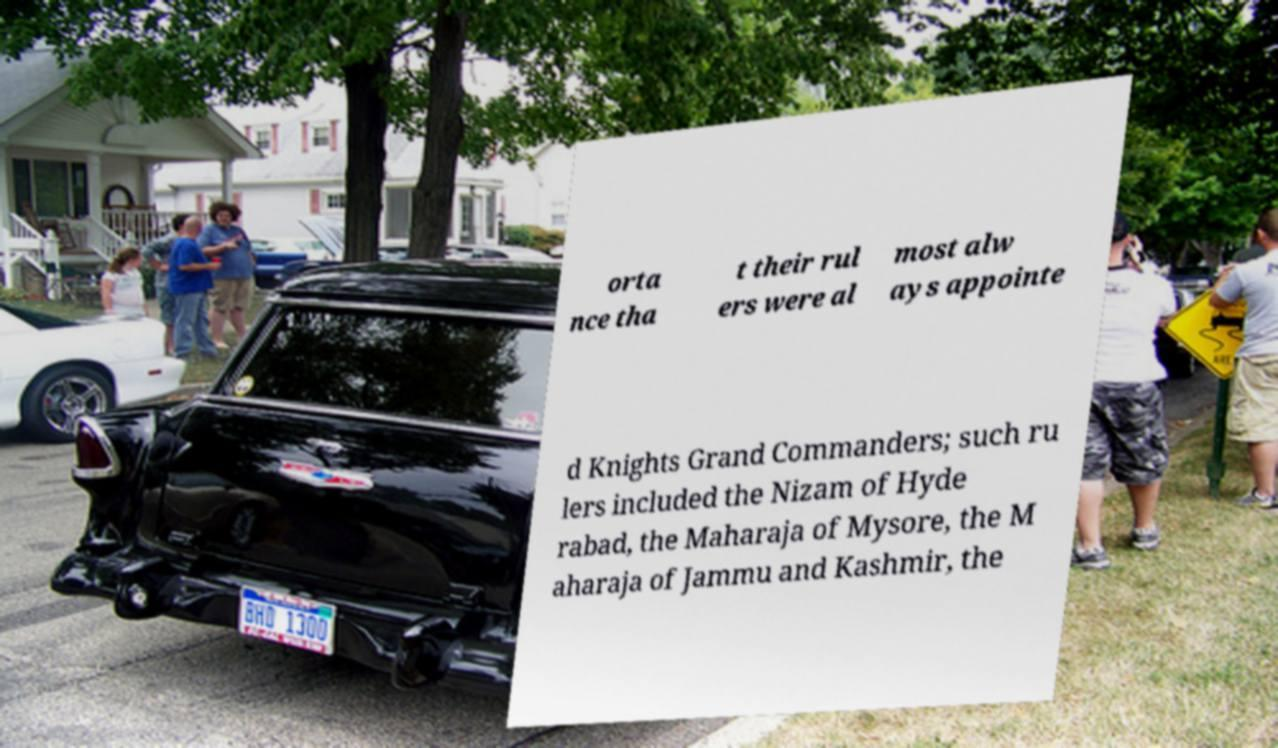What messages or text are displayed in this image? I need them in a readable, typed format. orta nce tha t their rul ers were al most alw ays appointe d Knights Grand Commanders; such ru lers included the Nizam of Hyde rabad, the Maharaja of Mysore, the M aharaja of Jammu and Kashmir, the 